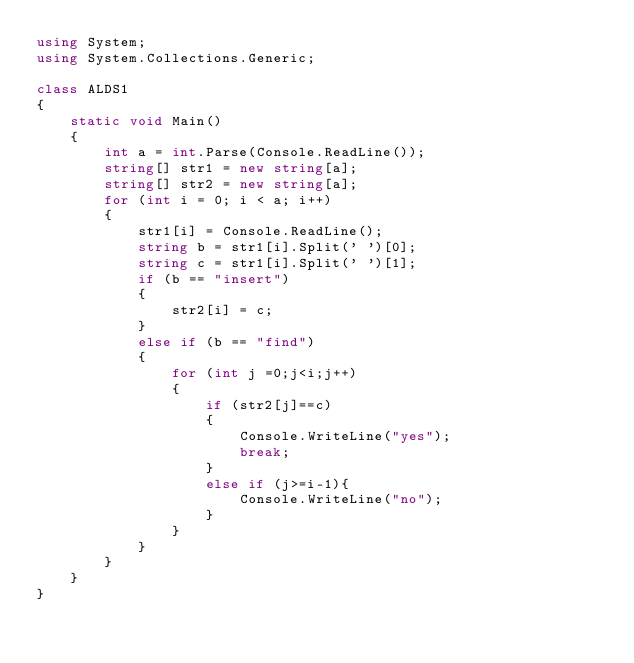<code> <loc_0><loc_0><loc_500><loc_500><_C#_>using System;
using System.Collections.Generic;

class ALDS1
{
    static void Main()
    {
        int a = int.Parse(Console.ReadLine());
        string[] str1 = new string[a];
        string[] str2 = new string[a];
        for (int i = 0; i < a; i++)
        {
            str1[i] = Console.ReadLine();
            string b = str1[i].Split(' ')[0];
            string c = str1[i].Split(' ')[1];
            if (b == "insert")
            {
                str2[i] = c;
            }
            else if (b == "find")
            {
                for (int j =0;j<i;j++)
                {
                    if (str2[j]==c)
                    {
                        Console.WriteLine("yes");
                        break;
                    }
                    else if (j>=i-1){
                        Console.WriteLine("no");
                    }
                }
            }
        }
    }
}</code> 